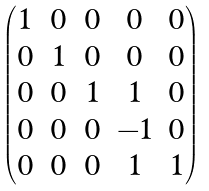Convert formula to latex. <formula><loc_0><loc_0><loc_500><loc_500>\begin{pmatrix} 1 & 0 & 0 & 0 & 0 \\ 0 & 1 & 0 & 0 & 0 \\ 0 & 0 & 1 & 1 & 0 \\ 0 & 0 & 0 & - 1 & 0 \\ 0 & 0 & 0 & 1 & 1 \end{pmatrix}</formula> 